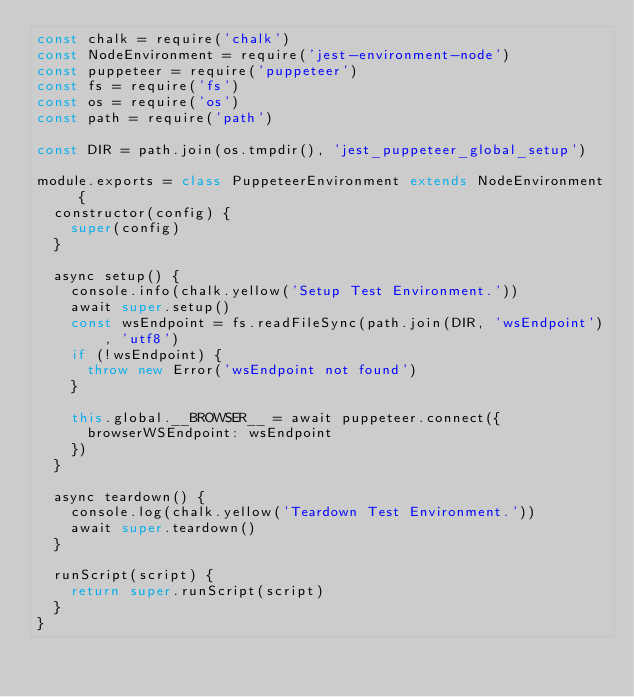Convert code to text. <code><loc_0><loc_0><loc_500><loc_500><_JavaScript_>const chalk = require('chalk')
const NodeEnvironment = require('jest-environment-node')
const puppeteer = require('puppeteer')
const fs = require('fs')
const os = require('os')
const path = require('path')

const DIR = path.join(os.tmpdir(), 'jest_puppeteer_global_setup')

module.exports = class PuppeteerEnvironment extends NodeEnvironment {
  constructor(config) {
    super(config)
  }

  async setup() {
    console.info(chalk.yellow('Setup Test Environment.'))
    await super.setup()
    const wsEndpoint = fs.readFileSync(path.join(DIR, 'wsEndpoint'), 'utf8')
    if (!wsEndpoint) {
      throw new Error('wsEndpoint not found')
    }

    this.global.__BROWSER__ = await puppeteer.connect({
      browserWSEndpoint: wsEndpoint
    })
  }

  async teardown() {
    console.log(chalk.yellow('Teardown Test Environment.'))
    await super.teardown()
  }

  runScript(script) {
    return super.runScript(script)
  }
}
</code> 